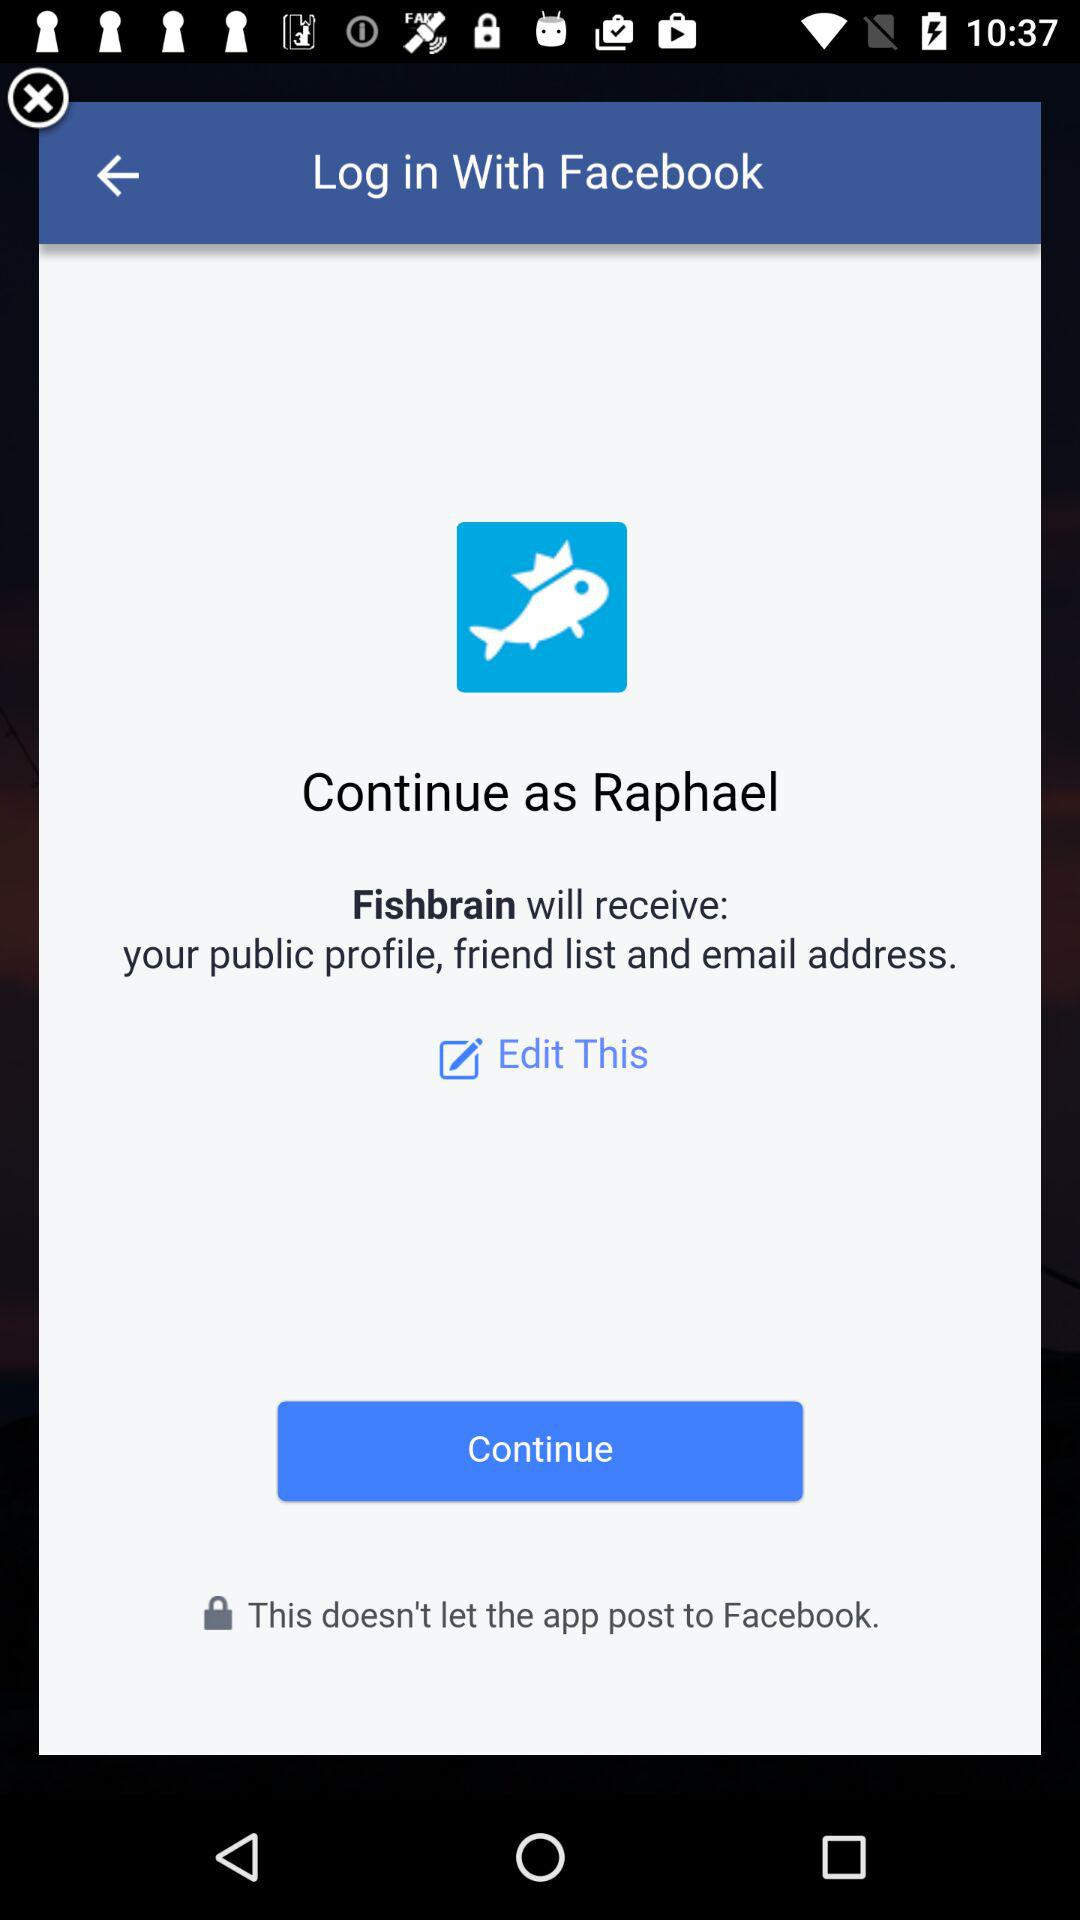What is the Application name?
When the provided information is insufficient, respond with <no answer>. <no answer> 